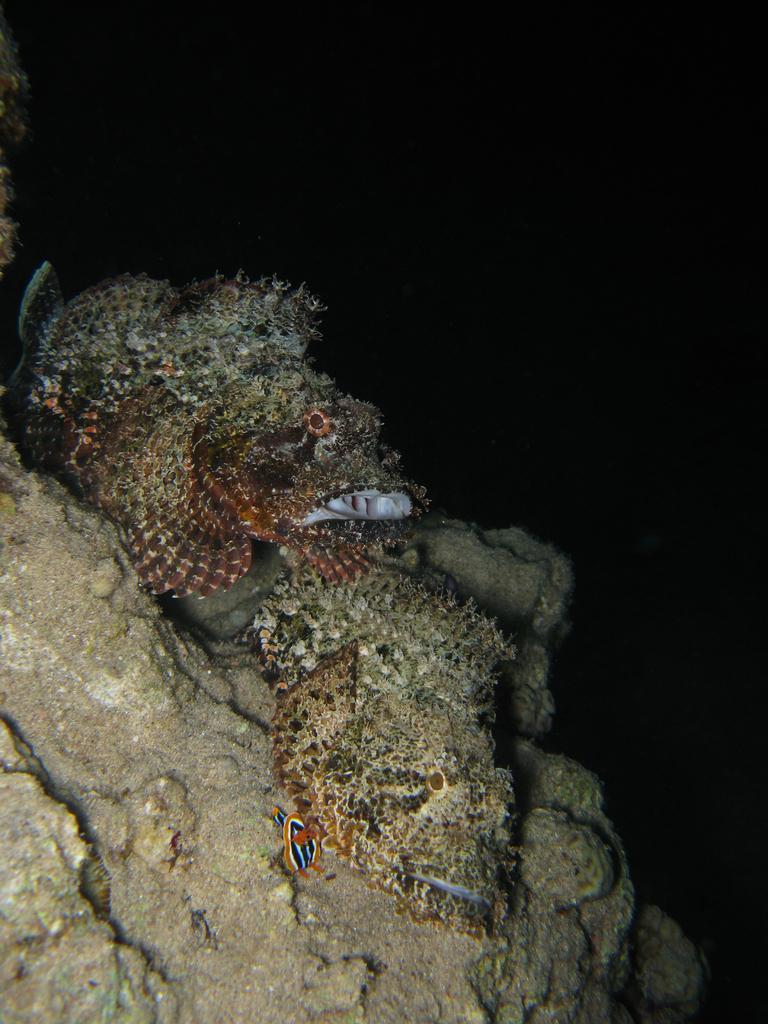In one or two sentences, can you explain what this image depicts? On the left side, there are fishes and there is moss and sand on the rocks, which are in the underground of the water. And the background is dark in color. 